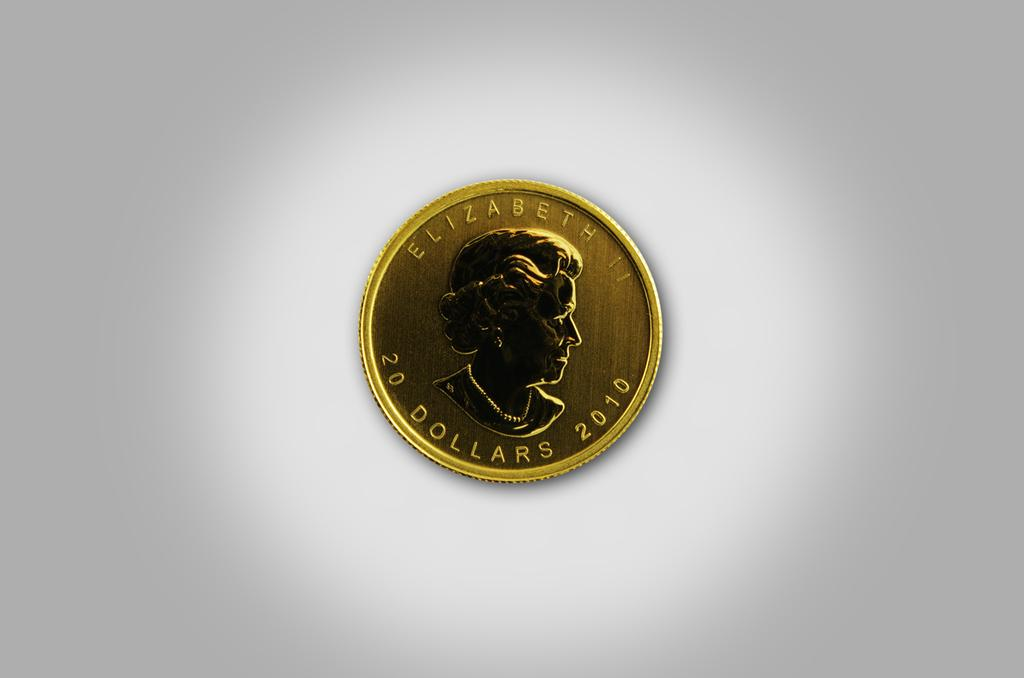Provide a one-sentence caption for the provided image. a golden coin that says 'elizabeth 20 dollars 2010' on it. 